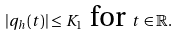<formula> <loc_0><loc_0><loc_500><loc_500>| q _ { h } ( t ) | \leq K _ { 1 } \text { for } t \in \mathbb { R } .</formula> 